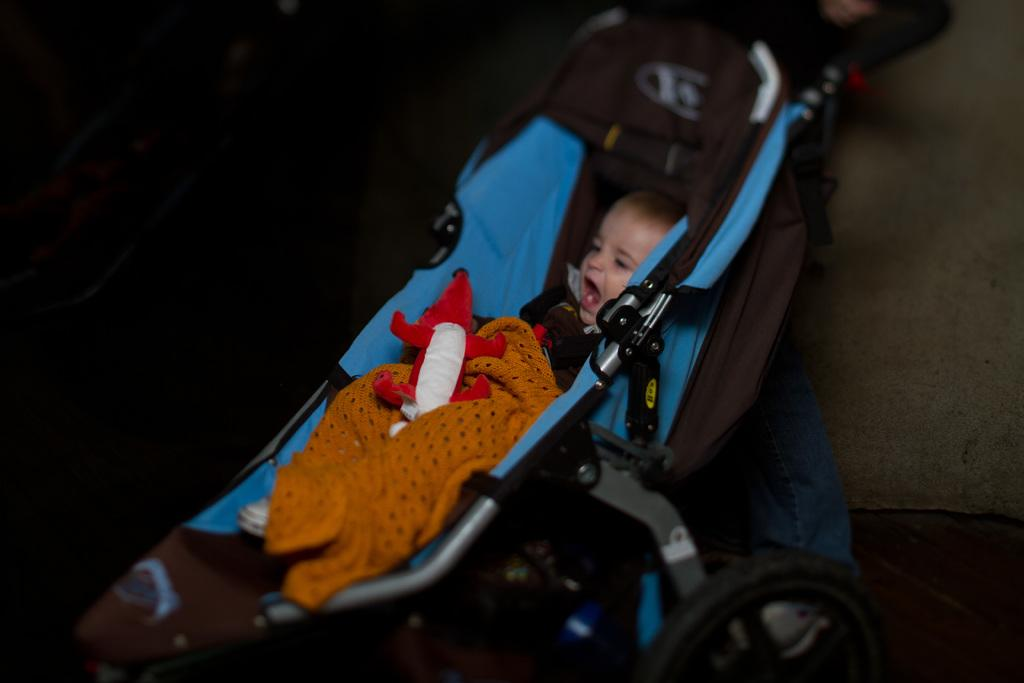What is the main subject of the image? The main subject of the image is a kid. What is the kid doing in the image? The kid is sitting in a trolley. What else can be seen in the image besides the kid? There is a toy, a cloth on the kid, the floor, and a wall in the background of the image. What trick is the grandfather performing with the horn in the image? There is no grandfather or horn present in the image. 